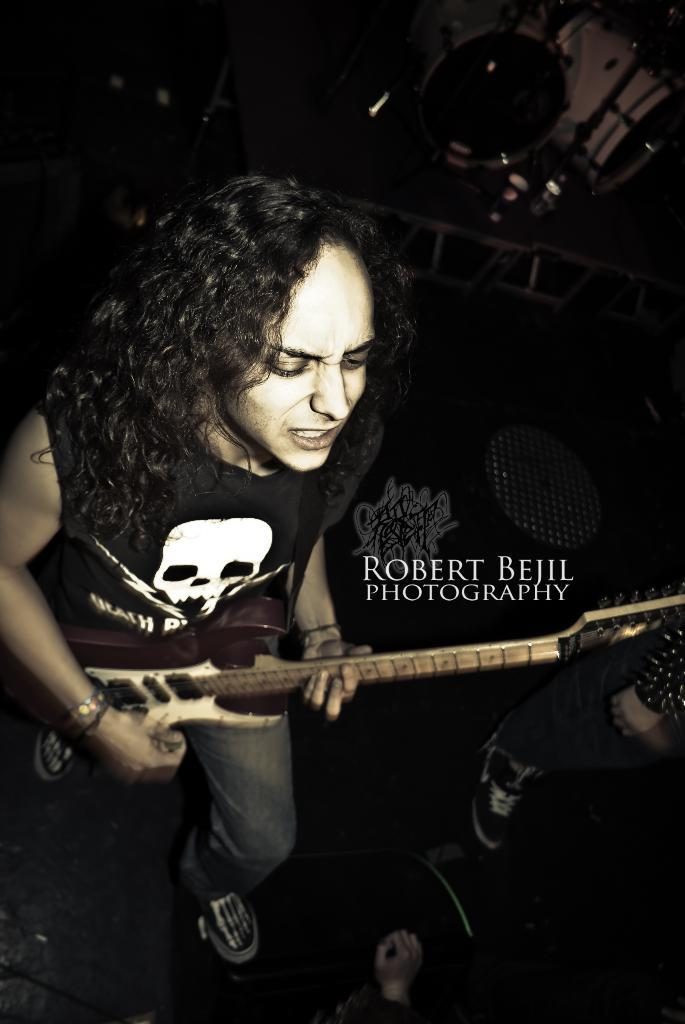What is the main activity of the person in the image? There is a person playing a guitar in the image. Can you describe the clothing of the guitar player? The person is wearing a black t-shirt with a skull printed on it and jeans. Are there any other people visible in the image? Yes, a person's leg is visible to the right of the guitar player. What other musical instrument can be seen in the image? There are drums visible in the background of the image. What type of mark can be seen on the sheep in the image? There are no sheep present in the image; it features a person playing a guitar and drums in the background. Is the rifle visible in the image? There is no rifle present in the image. 